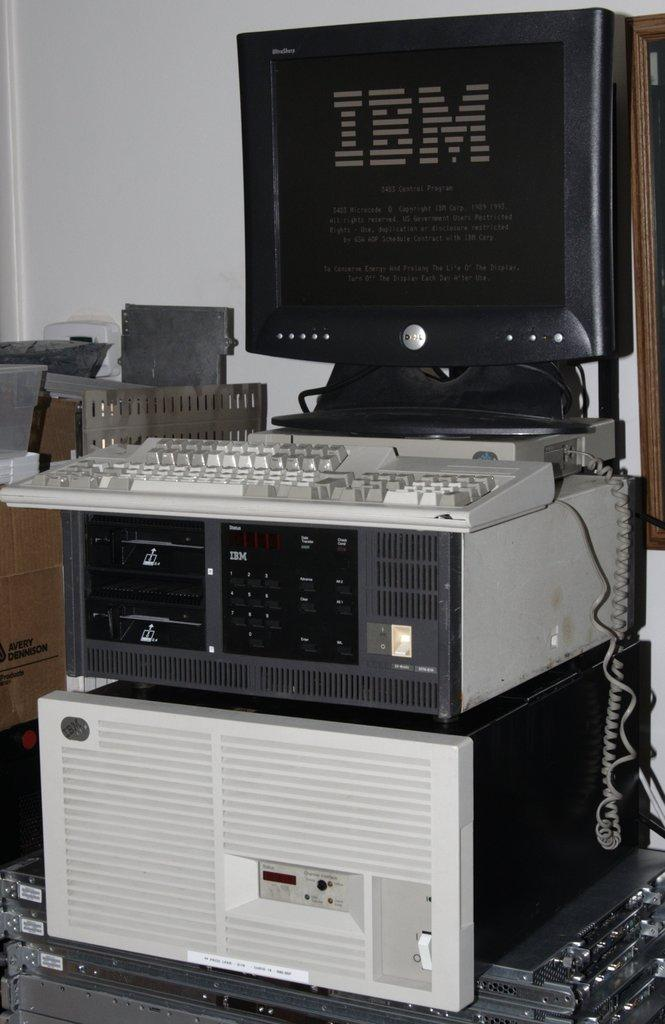<image>
Give a short and clear explanation of the subsequent image. An Dell computer monitor displaying the IBM logo on the  monitor screen.. 